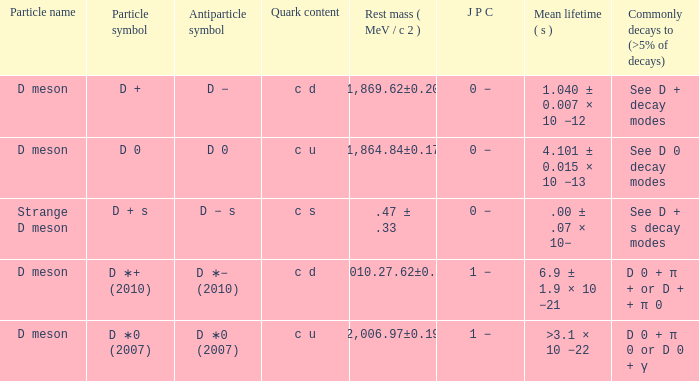What is the symbol for the antiparticle with a rest mass (mev/c2) of .47 ± .33? D − s. 